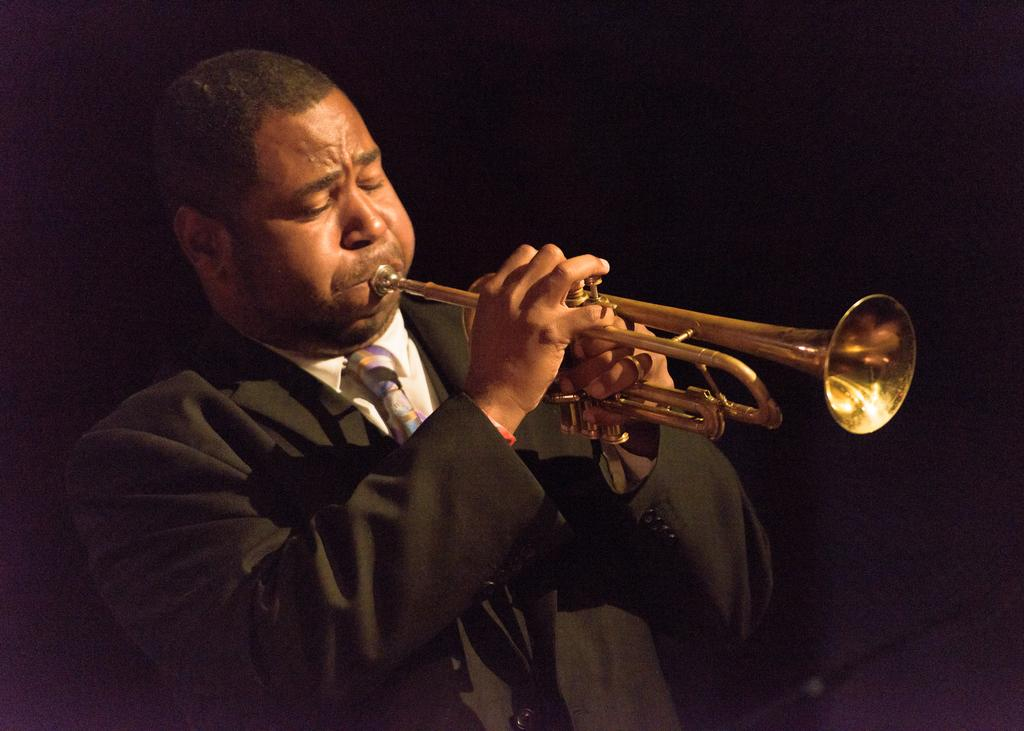What is the main subject of the image? The main subject of the image is a person. What is the person doing in the image? The person is playing a musical instrument in the image. Can you describe the background of the image? The background of the image is dark. What type of competition is taking place on the sidewalk in the image? There is no sidewalk or competition present in the image. How does the person establish their territory while playing the musical instrument in the image? The image does not show any territorial behavior or the need to establish territory. 